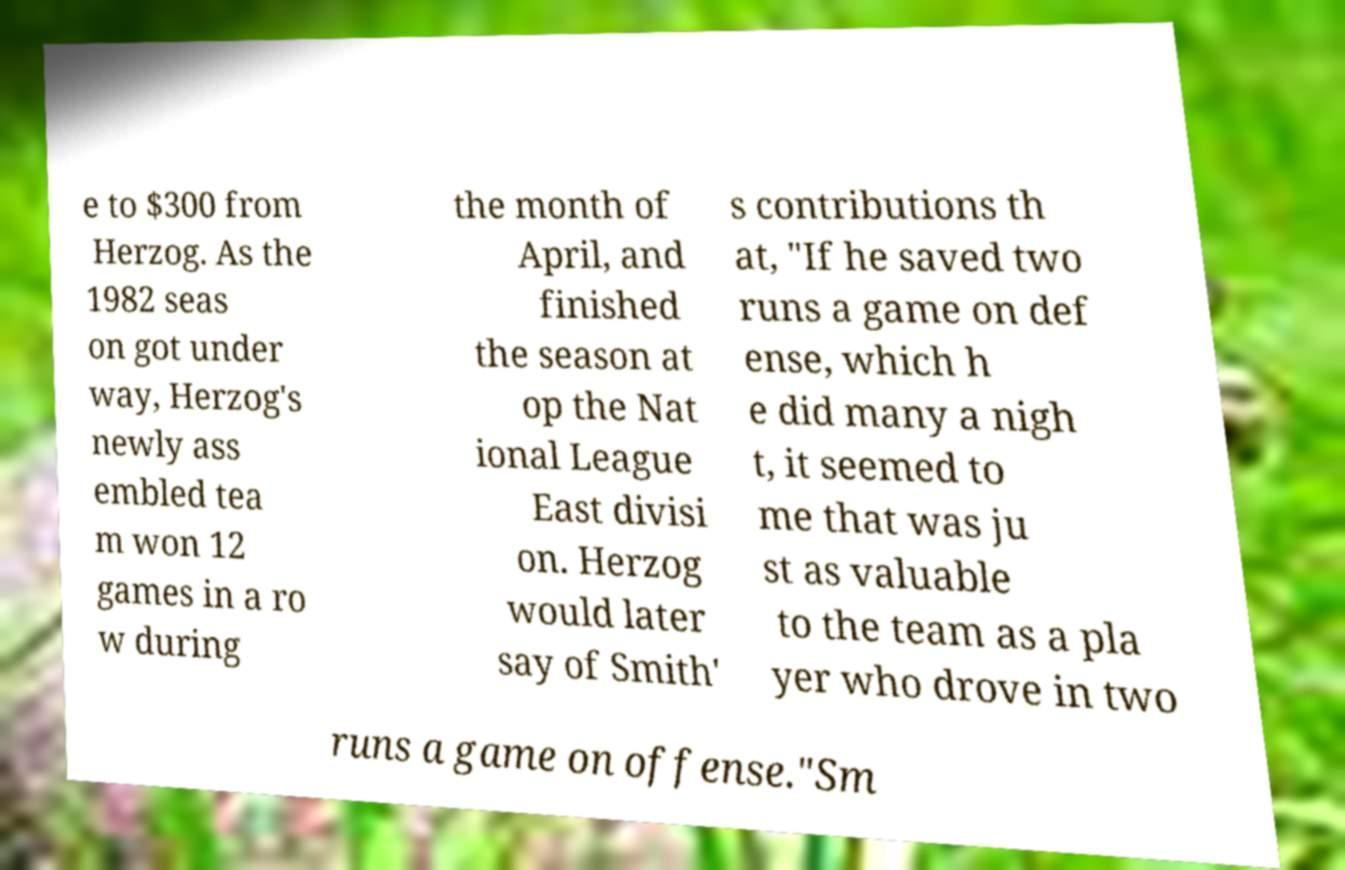Could you assist in decoding the text presented in this image and type it out clearly? e to $300 from Herzog. As the 1982 seas on got under way, Herzog's newly ass embled tea m won 12 games in a ro w during the month of April, and finished the season at op the Nat ional League East divisi on. Herzog would later say of Smith' s contributions th at, "If he saved two runs a game on def ense, which h e did many a nigh t, it seemed to me that was ju st as valuable to the team as a pla yer who drove in two runs a game on offense."Sm 